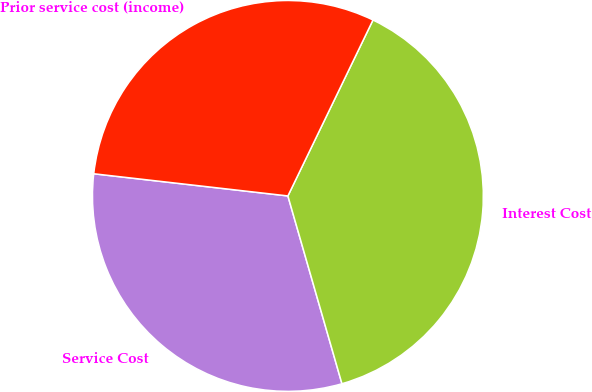Convert chart. <chart><loc_0><loc_0><loc_500><loc_500><pie_chart><fcel>Service Cost<fcel>Interest Cost<fcel>Prior service cost (income)<nl><fcel>31.27%<fcel>38.37%<fcel>30.36%<nl></chart> 